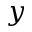<formula> <loc_0><loc_0><loc_500><loc_500>y</formula> 